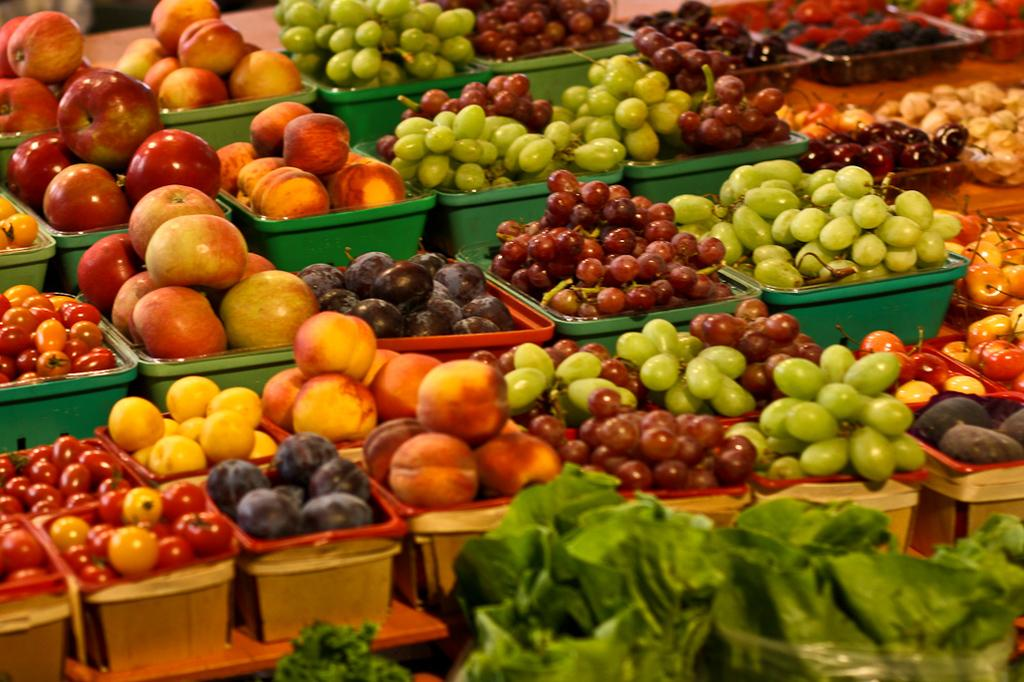What types of fruits can be seen in the image? There are apples, grapes, and other fruits in the image. How are the fruits arranged in the image? The fruits are arranged in baskets. What can be observed about the baskets in the image? The baskets are in different colors. What is placed in front of the baskets? There are leaves arranged in front of the baskets. What type of stitch is used to sew the carpenter's apron in the image? There is no carpenter or apron present in the image; it features fruits arranged in baskets with leaves in front. 